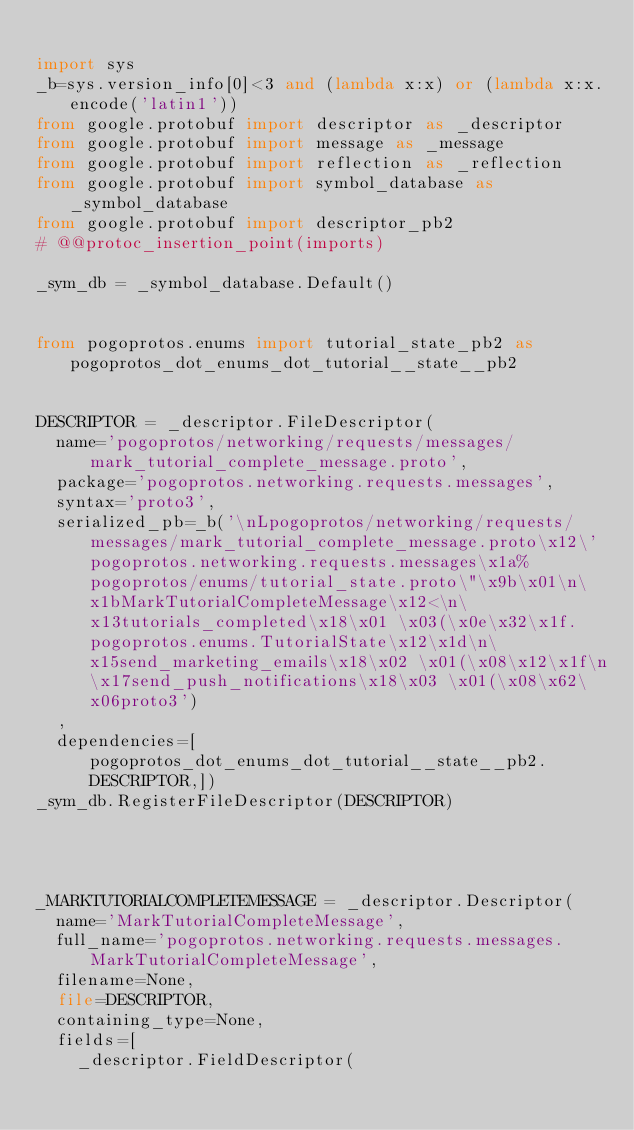Convert code to text. <code><loc_0><loc_0><loc_500><loc_500><_Python_>
import sys
_b=sys.version_info[0]<3 and (lambda x:x) or (lambda x:x.encode('latin1'))
from google.protobuf import descriptor as _descriptor
from google.protobuf import message as _message
from google.protobuf import reflection as _reflection
from google.protobuf import symbol_database as _symbol_database
from google.protobuf import descriptor_pb2
# @@protoc_insertion_point(imports)

_sym_db = _symbol_database.Default()


from pogoprotos.enums import tutorial_state_pb2 as pogoprotos_dot_enums_dot_tutorial__state__pb2


DESCRIPTOR = _descriptor.FileDescriptor(
  name='pogoprotos/networking/requests/messages/mark_tutorial_complete_message.proto',
  package='pogoprotos.networking.requests.messages',
  syntax='proto3',
  serialized_pb=_b('\nLpogoprotos/networking/requests/messages/mark_tutorial_complete_message.proto\x12\'pogoprotos.networking.requests.messages\x1a%pogoprotos/enums/tutorial_state.proto\"\x9b\x01\n\x1bMarkTutorialCompleteMessage\x12<\n\x13tutorials_completed\x18\x01 \x03(\x0e\x32\x1f.pogoprotos.enums.TutorialState\x12\x1d\n\x15send_marketing_emails\x18\x02 \x01(\x08\x12\x1f\n\x17send_push_notifications\x18\x03 \x01(\x08\x62\x06proto3')
  ,
  dependencies=[pogoprotos_dot_enums_dot_tutorial__state__pb2.DESCRIPTOR,])
_sym_db.RegisterFileDescriptor(DESCRIPTOR)




_MARKTUTORIALCOMPLETEMESSAGE = _descriptor.Descriptor(
  name='MarkTutorialCompleteMessage',
  full_name='pogoprotos.networking.requests.messages.MarkTutorialCompleteMessage',
  filename=None,
  file=DESCRIPTOR,
  containing_type=None,
  fields=[
    _descriptor.FieldDescriptor(</code> 